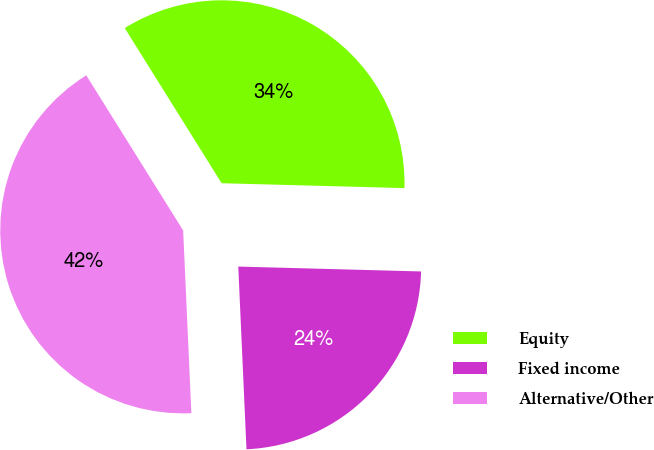Convert chart to OTSL. <chart><loc_0><loc_0><loc_500><loc_500><pie_chart><fcel>Equity<fcel>Fixed income<fcel>Alternative/Other<nl><fcel>34.31%<fcel>23.86%<fcel>41.83%<nl></chart> 